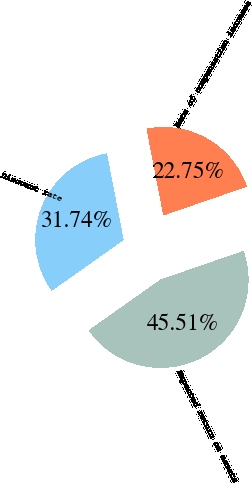Convert chart to OTSL. <chart><loc_0><loc_0><loc_500><loc_500><pie_chart><fcel>Discount rate<fcel>Expected return on assets<fcel>Rate of compensation increase<nl><fcel>31.74%<fcel>45.51%<fcel>22.75%<nl></chart> 